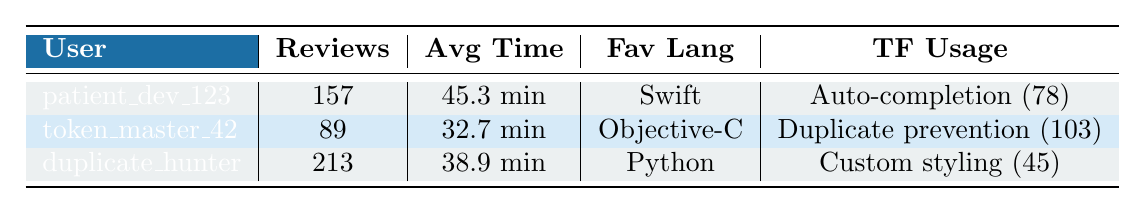What is the average review time for the users? To find the average review time, I add the avg review times of all users: (45.3 + 32.7 + 38.9) = 116.9 minutes. Then, I divide by the number of users (3), which gives me 116.9 / 3 = 39.63 (approximately 39.6 minutes).
Answer: 39.6 minutes Who has the highest total reviews? The user with the highest total reviews can be found by comparing the total reviews of each user: patient_dev_123 has 157, token_master_42 has 89, and duplicate_hunter has 213. The highest is 213 by duplicate_hunter.
Answer: duplicate_hunter Is patient_dev_123 using auto-completion? According to the table, patient_dev_123 has an entry for the feature auto-completion under TF Usage, which indicates that they are indeed using it.
Answer: Yes Which user has the lowest average review time? To determine the lowest average review time, I compare the average times: patient_dev_123 has 45.3, token_master_42 has 32.7, and duplicate_hunter has 38.9. The lowest average time is 32.7 for token_master_42.
Answer: token_master_42 What is the total number of reviews completed by all users? To calculate the total reviews, I sum the total reviews: 157 (patient_dev_123) + 89 (token_master_42) + 213 (duplicate_hunter) = 459.
Answer: 459 How many lines changed did duplicate_hunter review? Looking at the code reviews, duplicate_hunter is associated with review id 1003, which indicates that 65 lines were changed in that review.
Answer: 65 lines Did token_master_42 make any comments in their review? The table lists comments made during the code reviews, and for token_master_42 (review id 1002), there are 4 comments. Therefore, they did make comments.
Answer: Yes What feature did duplicate_hunter use, and how often? Checking the TF Usage, duplicate_hunter used the feature custom token styling, with a usage count of 45.
Answer: Custom token styling (45 times) If we combine the average review times of patient_dev_123 and duplicate_hunter, what is the result? I add their average review times: 45.3 (patient_dev_123) + 38.9 (duplicate_hunter) = 84.2 minutes.
Answer: 84.2 minutes Can you identify a user who is involved in a comment reply event? The first event in collaboration events shows that patient_dev_123 is involved in a comment reply directed at token_master_42.
Answer: Yes, patient_dev_123 